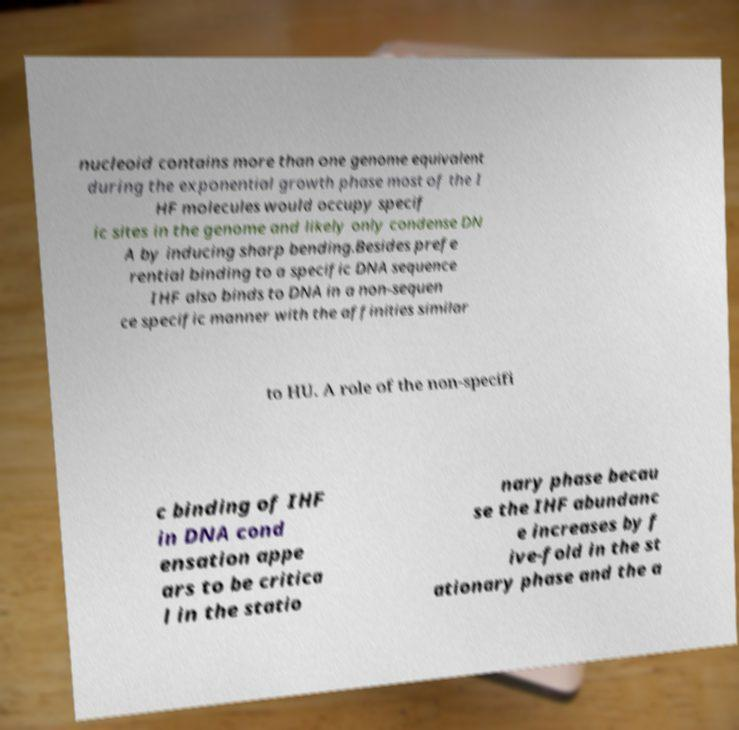What messages or text are displayed in this image? I need them in a readable, typed format. nucleoid contains more than one genome equivalent during the exponential growth phase most of the I HF molecules would occupy specif ic sites in the genome and likely only condense DN A by inducing sharp bending.Besides prefe rential binding to a specific DNA sequence IHF also binds to DNA in a non-sequen ce specific manner with the affinities similar to HU. A role of the non-specifi c binding of IHF in DNA cond ensation appe ars to be critica l in the statio nary phase becau se the IHF abundanc e increases by f ive-fold in the st ationary phase and the a 